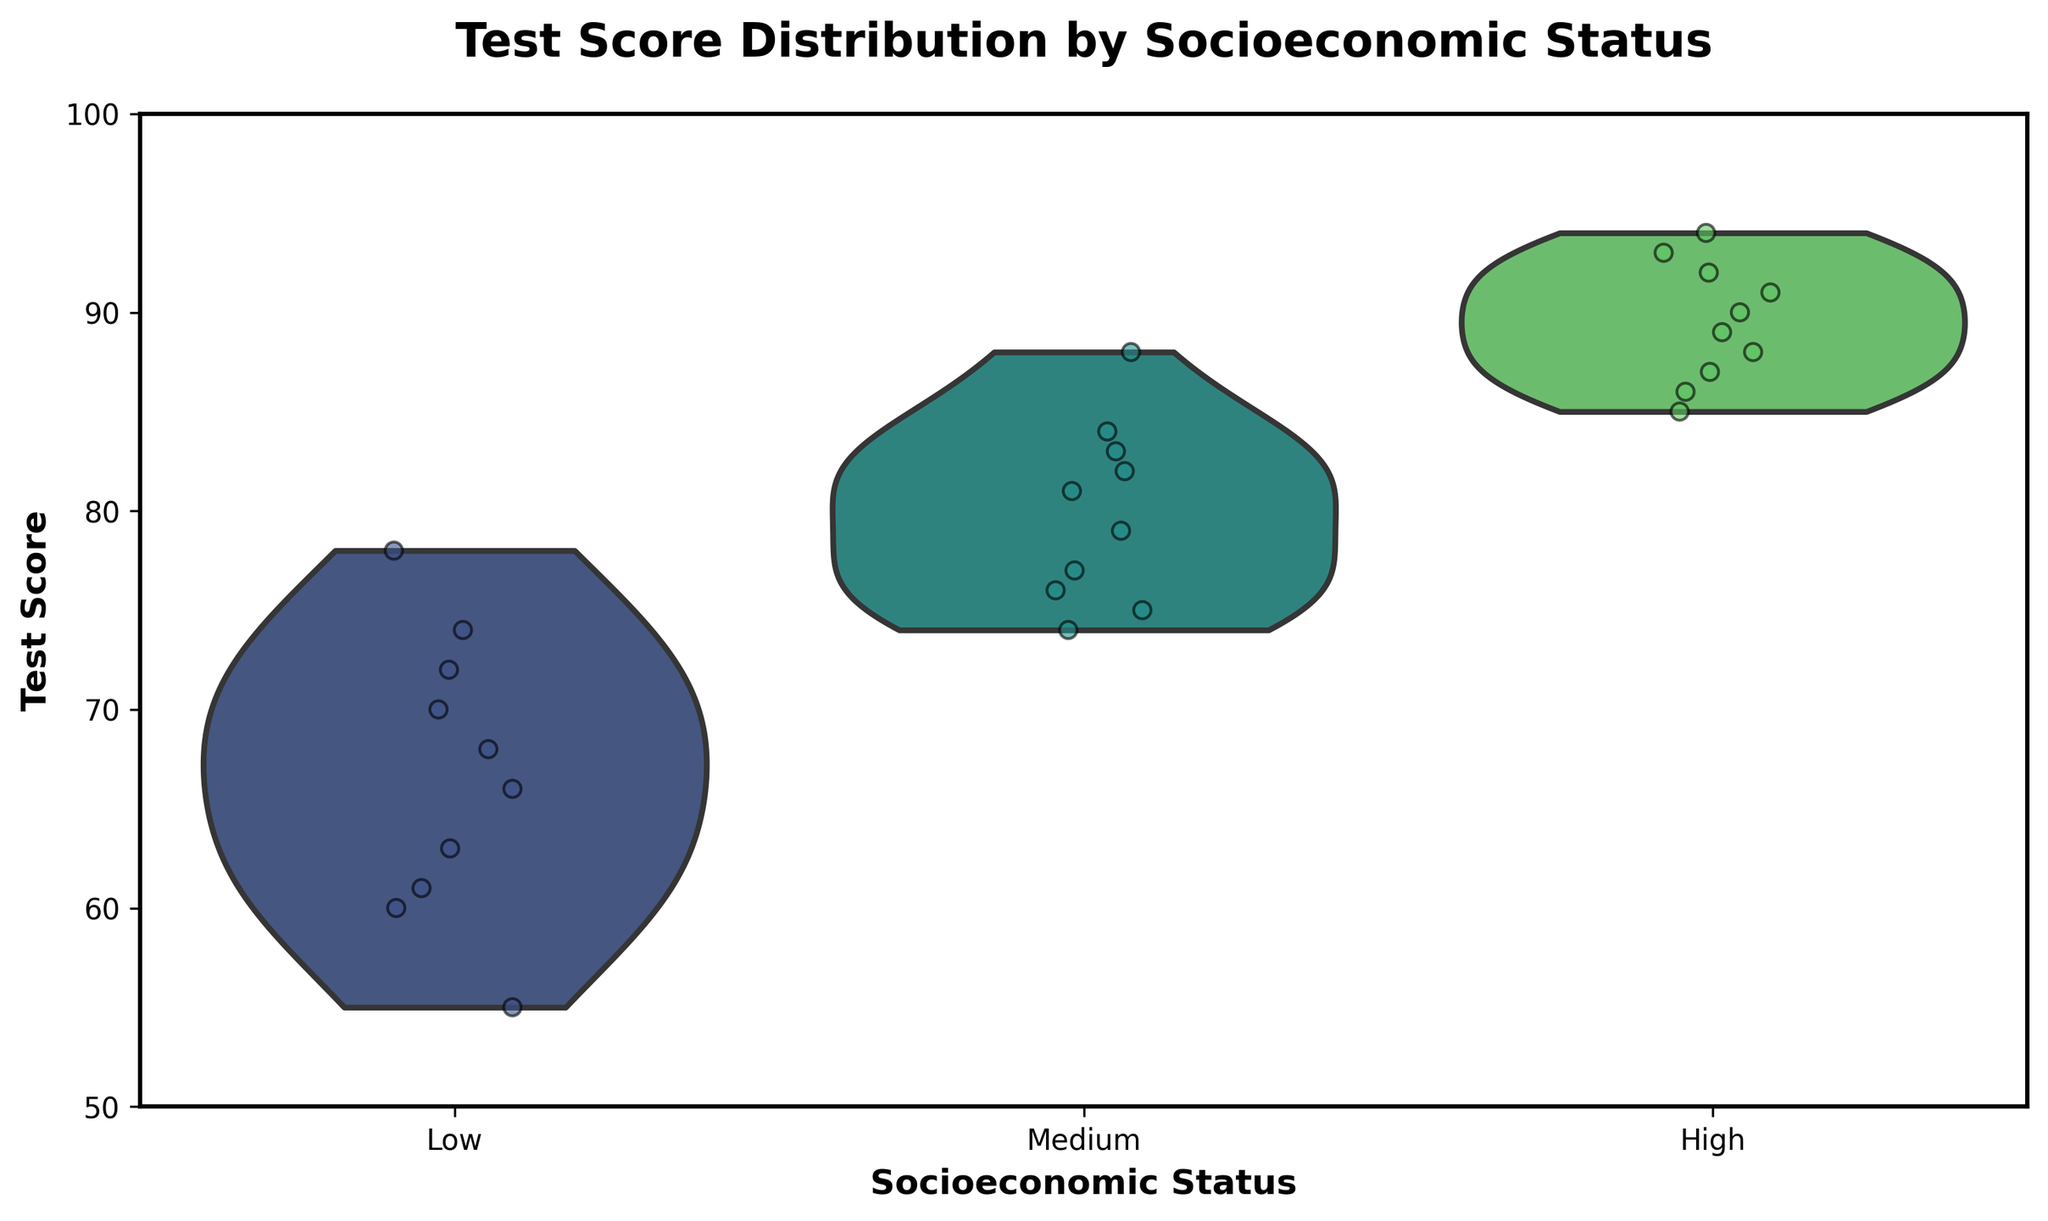What is the title of the figure? The title of the figure is displayed at the top of the chart.
Answer: Test Score Distribution by Socioeconomic Status What are the three socioeconomic status categories shown in the figure? The categories can be seen along the x-axis showing different group labels.
Answer: Low, Medium, High Which socioeconomic group has the highest median test score? From the violin plots, the thickest part of each plot shows the median. The 'High' group has the highest median test score.
Answer: High How many test score points are shown for the 'Medium' socioeconomic group? By counting the individual data points (dots) jittered in the 'Medium' group section, there are 10 points.
Answer: 10 What is the range of test scores for the 'Low' socioeconomic group? Observing the spread of the jittered points within the 'Low' group, the minimum score is 55, and the maximum score is 78. The range is 78 - 55 = 23.
Answer: 23 Compare the spread of test scores between the 'High' and 'Low' groups. Which group has a larger spread? The spread (range) can be seen as the distance covered by the jittered points. The 'Low' group's scores range from 55 to 78, while the 'High' group's scores range from 85 to 94. The 'Low' group has a larger spread of 23, compared to the 'High' group's spread of 9.
Answer: Low What color palette is used in the figure? The color palette used can be deduced from the general color scheme which is consistent throughout all plot elements.
Answer: Viridis Identify the group with the smallest interquartile range (IQR). The interquartile range (IQR) can be inferred from the width of the violin plot in the middle 50% range. The 'High' group has the smallest IQR due to the narrow spread in the middle of its violin plot.
Answer: High 